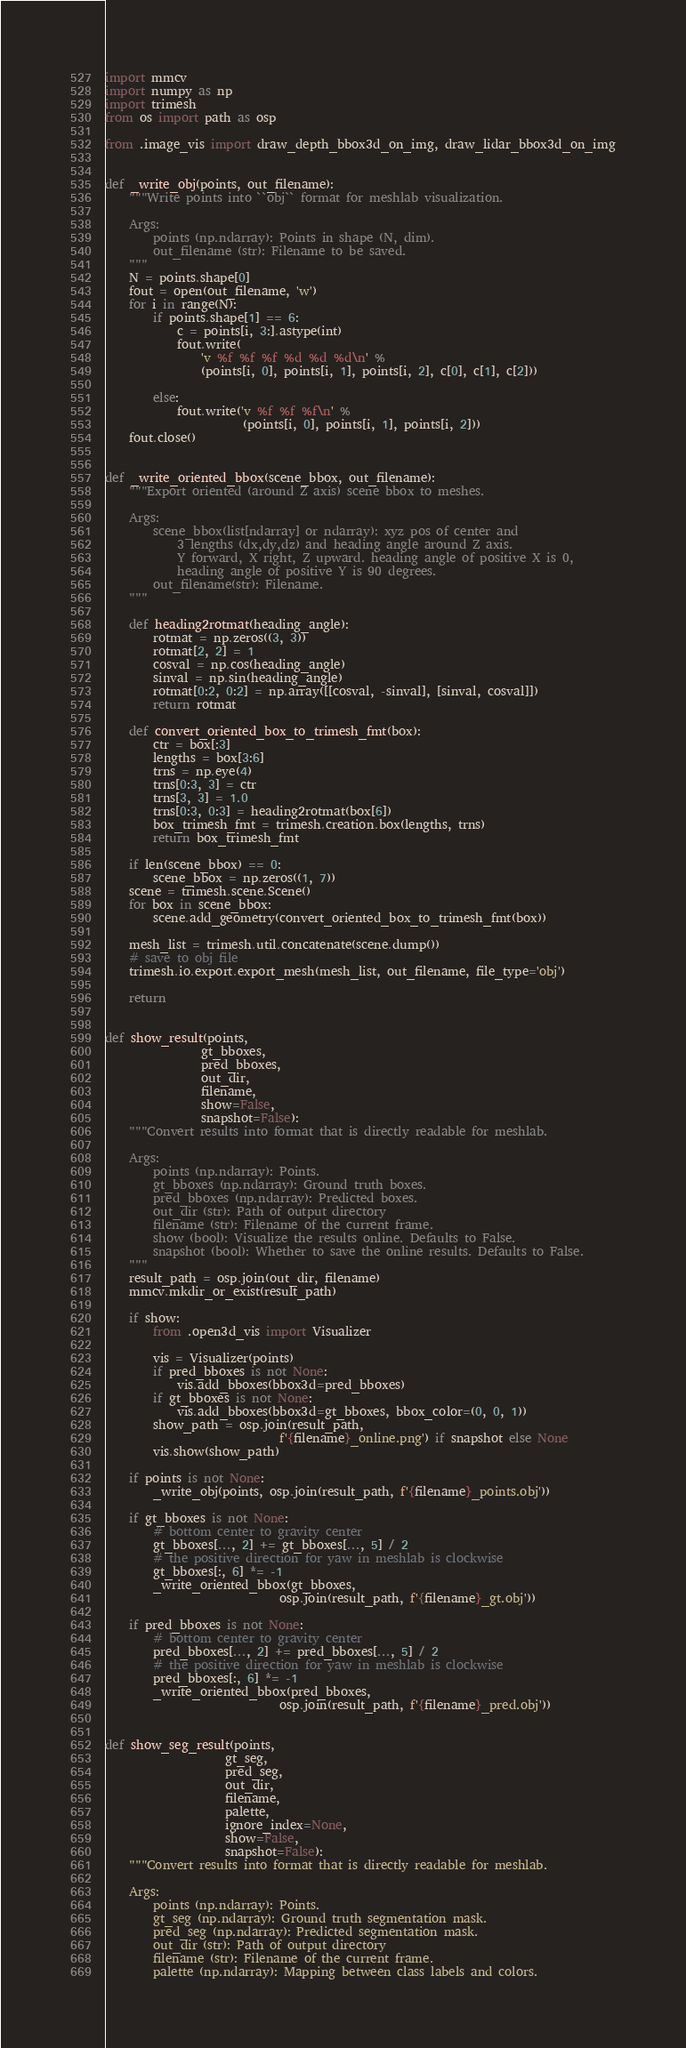<code> <loc_0><loc_0><loc_500><loc_500><_Python_>import mmcv
import numpy as np
import trimesh
from os import path as osp

from .image_vis import draw_depth_bbox3d_on_img, draw_lidar_bbox3d_on_img


def _write_obj(points, out_filename):
    """Write points into ``obj`` format for meshlab visualization.

    Args:
        points (np.ndarray): Points in shape (N, dim).
        out_filename (str): Filename to be saved.
    """
    N = points.shape[0]
    fout = open(out_filename, 'w')
    for i in range(N):
        if points.shape[1] == 6:
            c = points[i, 3:].astype(int)
            fout.write(
                'v %f %f %f %d %d %d\n' %
                (points[i, 0], points[i, 1], points[i, 2], c[0], c[1], c[2]))

        else:
            fout.write('v %f %f %f\n' %
                       (points[i, 0], points[i, 1], points[i, 2]))
    fout.close()


def _write_oriented_bbox(scene_bbox, out_filename):
    """Export oriented (around Z axis) scene bbox to meshes.

    Args:
        scene_bbox(list[ndarray] or ndarray): xyz pos of center and
            3 lengths (dx,dy,dz) and heading angle around Z axis.
            Y forward, X right, Z upward. heading angle of positive X is 0,
            heading angle of positive Y is 90 degrees.
        out_filename(str): Filename.
    """

    def heading2rotmat(heading_angle):
        rotmat = np.zeros((3, 3))
        rotmat[2, 2] = 1
        cosval = np.cos(heading_angle)
        sinval = np.sin(heading_angle)
        rotmat[0:2, 0:2] = np.array([[cosval, -sinval], [sinval, cosval]])
        return rotmat

    def convert_oriented_box_to_trimesh_fmt(box):
        ctr = box[:3]
        lengths = box[3:6]
        trns = np.eye(4)
        trns[0:3, 3] = ctr
        trns[3, 3] = 1.0
        trns[0:3, 0:3] = heading2rotmat(box[6])
        box_trimesh_fmt = trimesh.creation.box(lengths, trns)
        return box_trimesh_fmt

    if len(scene_bbox) == 0:
        scene_bbox = np.zeros((1, 7))
    scene = trimesh.scene.Scene()
    for box in scene_bbox:
        scene.add_geometry(convert_oriented_box_to_trimesh_fmt(box))

    mesh_list = trimesh.util.concatenate(scene.dump())
    # save to obj file
    trimesh.io.export.export_mesh(mesh_list, out_filename, file_type='obj')

    return


def show_result(points,
                gt_bboxes,
                pred_bboxes,
                out_dir,
                filename,
                show=False,
                snapshot=False):
    """Convert results into format that is directly readable for meshlab.

    Args:
        points (np.ndarray): Points.
        gt_bboxes (np.ndarray): Ground truth boxes.
        pred_bboxes (np.ndarray): Predicted boxes.
        out_dir (str): Path of output directory
        filename (str): Filename of the current frame.
        show (bool): Visualize the results online. Defaults to False.
        snapshot (bool): Whether to save the online results. Defaults to False.
    """
    result_path = osp.join(out_dir, filename)
    mmcv.mkdir_or_exist(result_path)

    if show:
        from .open3d_vis import Visualizer

        vis = Visualizer(points)
        if pred_bboxes is not None:
            vis.add_bboxes(bbox3d=pred_bboxes)
        if gt_bboxes is not None:
            vis.add_bboxes(bbox3d=gt_bboxes, bbox_color=(0, 0, 1))
        show_path = osp.join(result_path,
                             f'{filename}_online.png') if snapshot else None
        vis.show(show_path)

    if points is not None:
        _write_obj(points, osp.join(result_path, f'{filename}_points.obj'))

    if gt_bboxes is not None:
        # bottom center to gravity center
        gt_bboxes[..., 2] += gt_bboxes[..., 5] / 2
        # the positive direction for yaw in meshlab is clockwise
        gt_bboxes[:, 6] *= -1
        _write_oriented_bbox(gt_bboxes,
                             osp.join(result_path, f'{filename}_gt.obj'))

    if pred_bboxes is not None:
        # bottom center to gravity center
        pred_bboxes[..., 2] += pred_bboxes[..., 5] / 2
        # the positive direction for yaw in meshlab is clockwise
        pred_bboxes[:, 6] *= -1
        _write_oriented_bbox(pred_bboxes,
                             osp.join(result_path, f'{filename}_pred.obj'))


def show_seg_result(points,
                    gt_seg,
                    pred_seg,
                    out_dir,
                    filename,
                    palette,
                    ignore_index=None,
                    show=False,
                    snapshot=False):
    """Convert results into format that is directly readable for meshlab.

    Args:
        points (np.ndarray): Points.
        gt_seg (np.ndarray): Ground truth segmentation mask.
        pred_seg (np.ndarray): Predicted segmentation mask.
        out_dir (str): Path of output directory
        filename (str): Filename of the current frame.
        palette (np.ndarray): Mapping between class labels and colors.</code> 